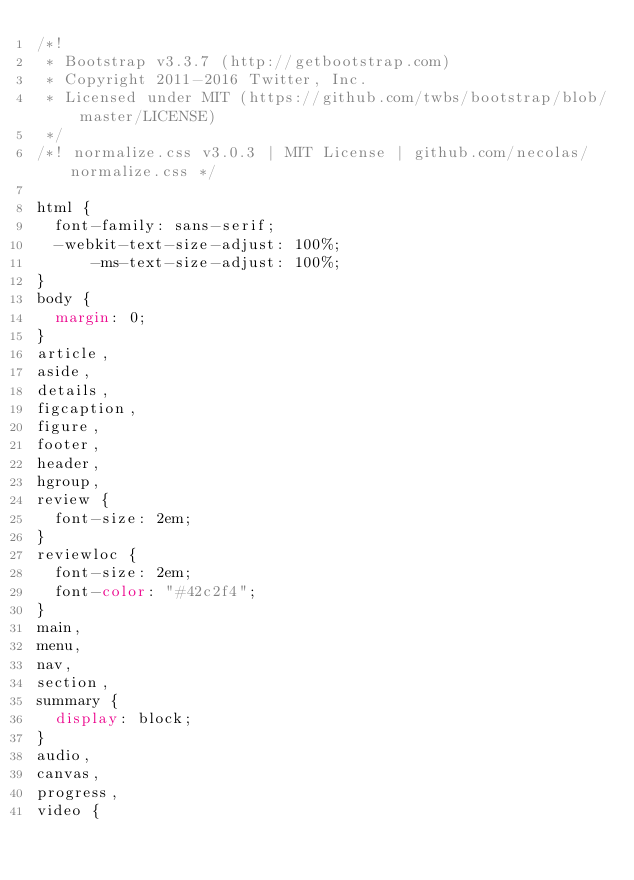<code> <loc_0><loc_0><loc_500><loc_500><_CSS_>/*!
 * Bootstrap v3.3.7 (http://getbootstrap.com)
 * Copyright 2011-2016 Twitter, Inc.
 * Licensed under MIT (https://github.com/twbs/bootstrap/blob/master/LICENSE)
 */
/*! normalize.css v3.0.3 | MIT License | github.com/necolas/normalize.css */

html {
  font-family: sans-serif;
  -webkit-text-size-adjust: 100%;
      -ms-text-size-adjust: 100%;
}
body {
  margin: 0;
}
article,
aside,
details,
figcaption,
figure,
footer,
header,
hgroup,
review {
  font-size: 2em;
}
reviewloc {
  font-size: 2em;
  font-color: "#42c2f4";
}
main,
menu,
nav,
section,
summary {
  display: block;
}
audio,
canvas,
progress,
video {</code> 